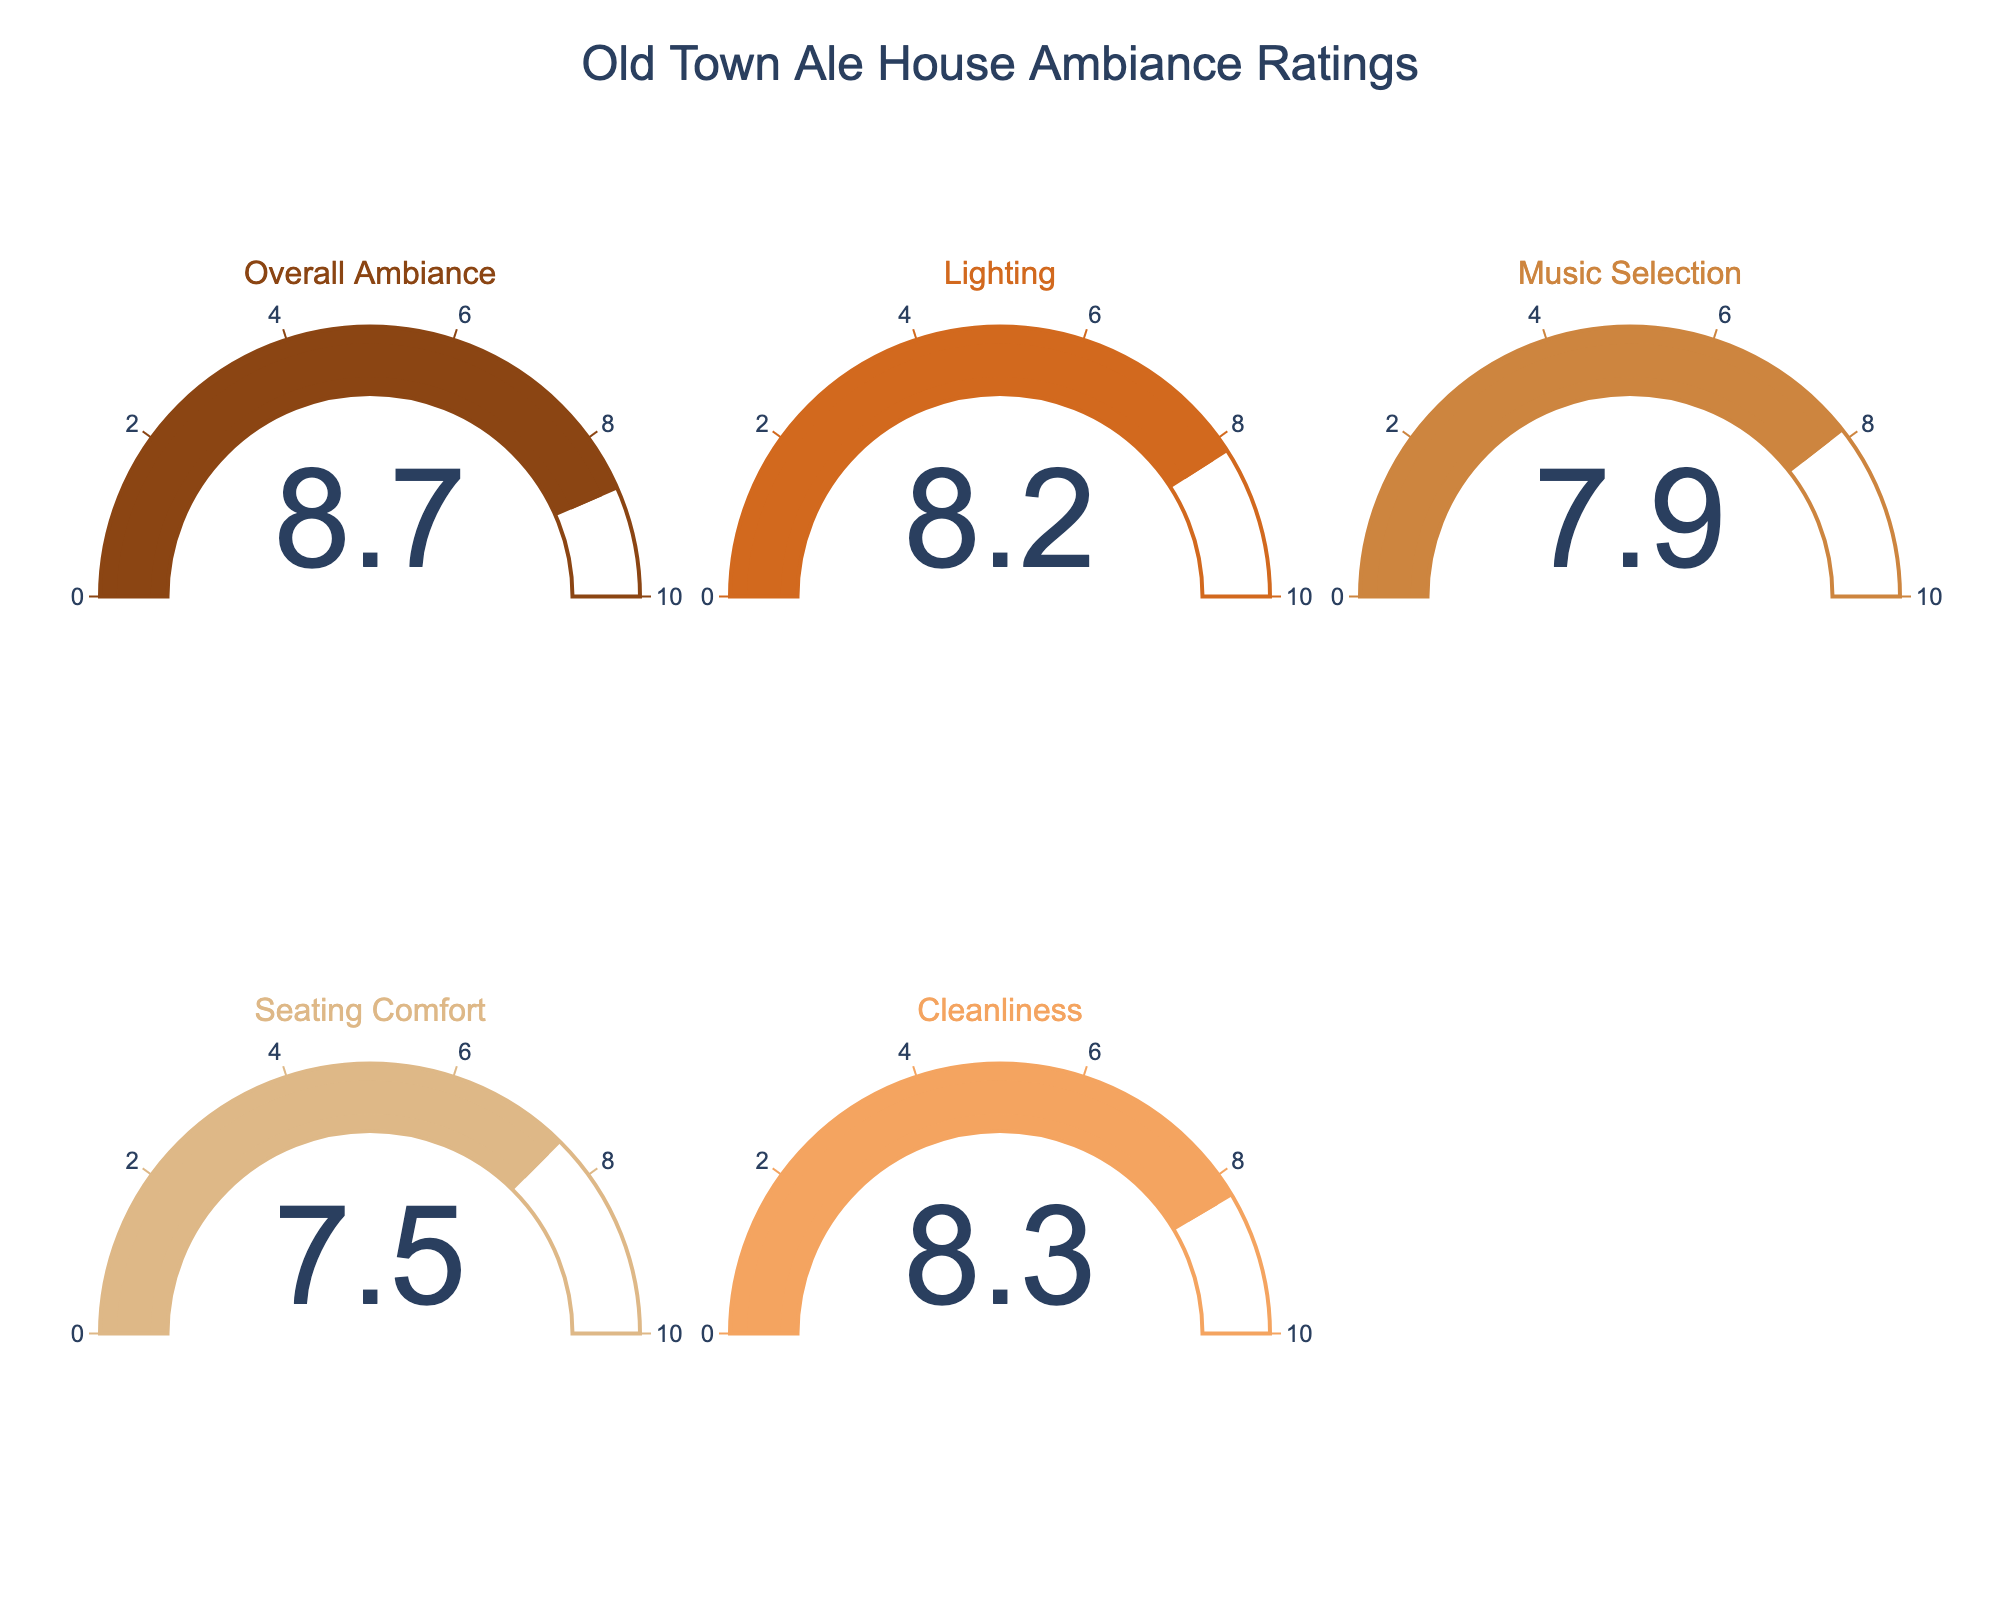what is the average rating for the Old Town Ale House ambiance overall? The gauge chart shows an overall ambiance rating value of 8.7. So, the average rating for overall ambiance is 8.7
Answer: 8.7 How does the lighting rating compare to the music selection rating? The gauge chart shows that the lighting rating is 8.2, while the music selection rating is 7.9. Comparing these two values, 8.2 is greater than 7.9.
Answer: Lighting is higher Which category has the lowest satisfaction rating? Among the gauge charts, the seating comfort category shows the lowest satisfaction rating of 7.5.
Answer: Seating Comfort What is the difference between the cleanliness and seating comfort ratings? The gauge chart shows cleanliness with a rating of 8.3 and seating comfort with a rating of 7.5. Subtracting these values, 8.3 - 7.5 = 0.8.
Answer: 0.8 What's the median rating of all the categories? The ratings are overall ambiance (8.7), lighting (8.2), music selection (7.9), seating comfort (7.5), and cleanliness (8.3). Arranging these values in ascending order gives: 7.5, 7.9, 8.2, 8.3, 8.7. The middle value, which is the median, is 8.2.
Answer: 8.2 What's the sum of all the ratings? The ratings are overall ambiance (8.7), lighting (8.2), music selection (7.9), seating comfort (7.5), and cleanliness (8.3). Summing these values: 8.7 + 8.2 + 7.9 + 7.5 + 8.3 = 40.6.
Answer: 40.6 Which categories have a rating above 8? The gauge chart shows that the categories with ratings above 8 are overall ambiance (8.7), lighting (8.2), and cleanliness (8.3).
Answer: Overall Ambiance, Lighting, Cleanliness How much higher is the overall ambiance rating compared to the music selection rating? The gauge chart shows overall ambiance has a rating of 8.7 and music selection has a rating of 7.9. Subtracting these values, 8.7 - 7.9 = 0.8.
Answer: 0.8 